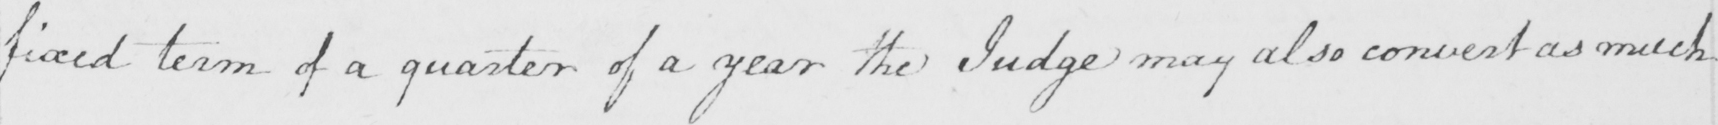Please transcribe the handwritten text in this image. fixed term of a quarter of a year the Judge may also convert as much 